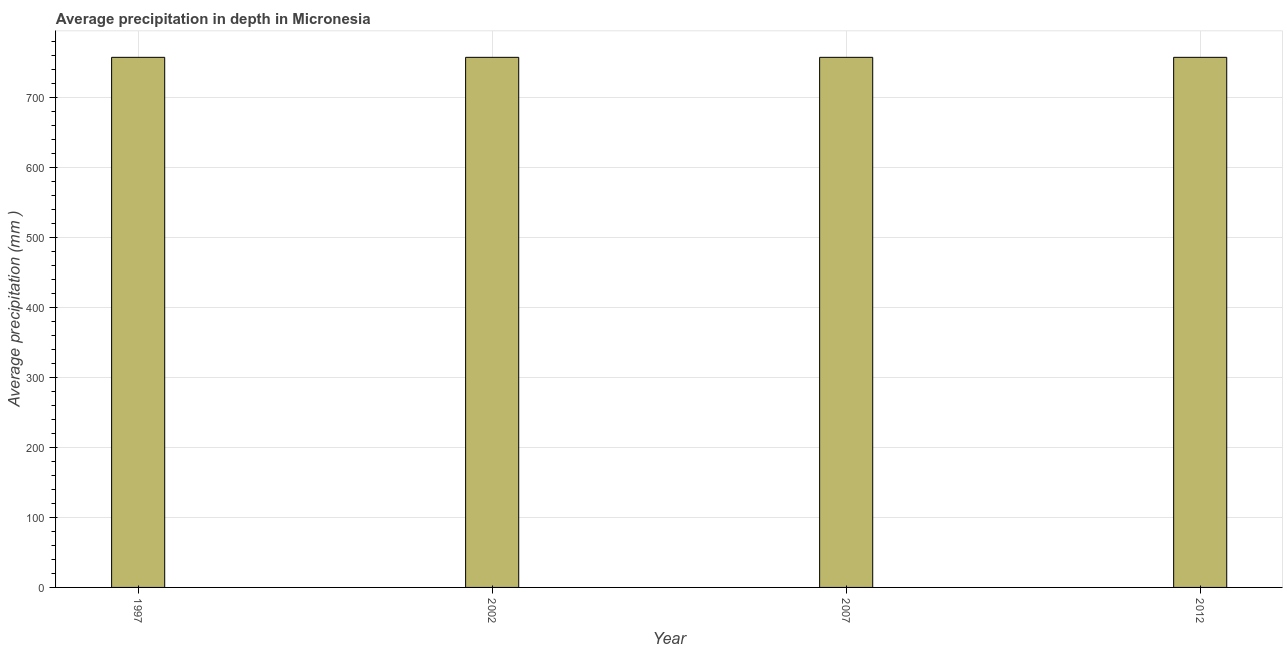Does the graph contain any zero values?
Give a very brief answer. No. What is the title of the graph?
Offer a very short reply. Average precipitation in depth in Micronesia. What is the label or title of the Y-axis?
Ensure brevity in your answer.  Average precipitation (mm ). What is the average precipitation in depth in 2012?
Your response must be concise. 758. Across all years, what is the maximum average precipitation in depth?
Your answer should be very brief. 758. Across all years, what is the minimum average precipitation in depth?
Offer a terse response. 758. In which year was the average precipitation in depth minimum?
Your response must be concise. 1997. What is the sum of the average precipitation in depth?
Give a very brief answer. 3032. What is the average average precipitation in depth per year?
Your response must be concise. 758. What is the median average precipitation in depth?
Provide a short and direct response. 758. What is the ratio of the average precipitation in depth in 2002 to that in 2007?
Keep it short and to the point. 1. How many years are there in the graph?
Your response must be concise. 4. Are the values on the major ticks of Y-axis written in scientific E-notation?
Provide a succinct answer. No. What is the Average precipitation (mm ) of 1997?
Make the answer very short. 758. What is the Average precipitation (mm ) in 2002?
Provide a short and direct response. 758. What is the Average precipitation (mm ) in 2007?
Provide a short and direct response. 758. What is the Average precipitation (mm ) in 2012?
Your response must be concise. 758. What is the difference between the Average precipitation (mm ) in 1997 and 2007?
Offer a very short reply. 0. What is the difference between the Average precipitation (mm ) in 1997 and 2012?
Offer a very short reply. 0. What is the difference between the Average precipitation (mm ) in 2007 and 2012?
Your answer should be very brief. 0. What is the ratio of the Average precipitation (mm ) in 1997 to that in 2007?
Ensure brevity in your answer.  1. What is the ratio of the Average precipitation (mm ) in 2002 to that in 2012?
Provide a succinct answer. 1. 